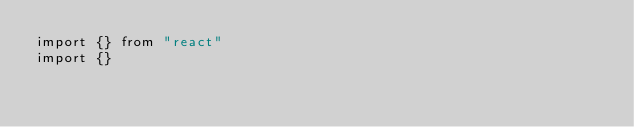<code> <loc_0><loc_0><loc_500><loc_500><_TypeScript_>import {} from "react"
import {}</code> 